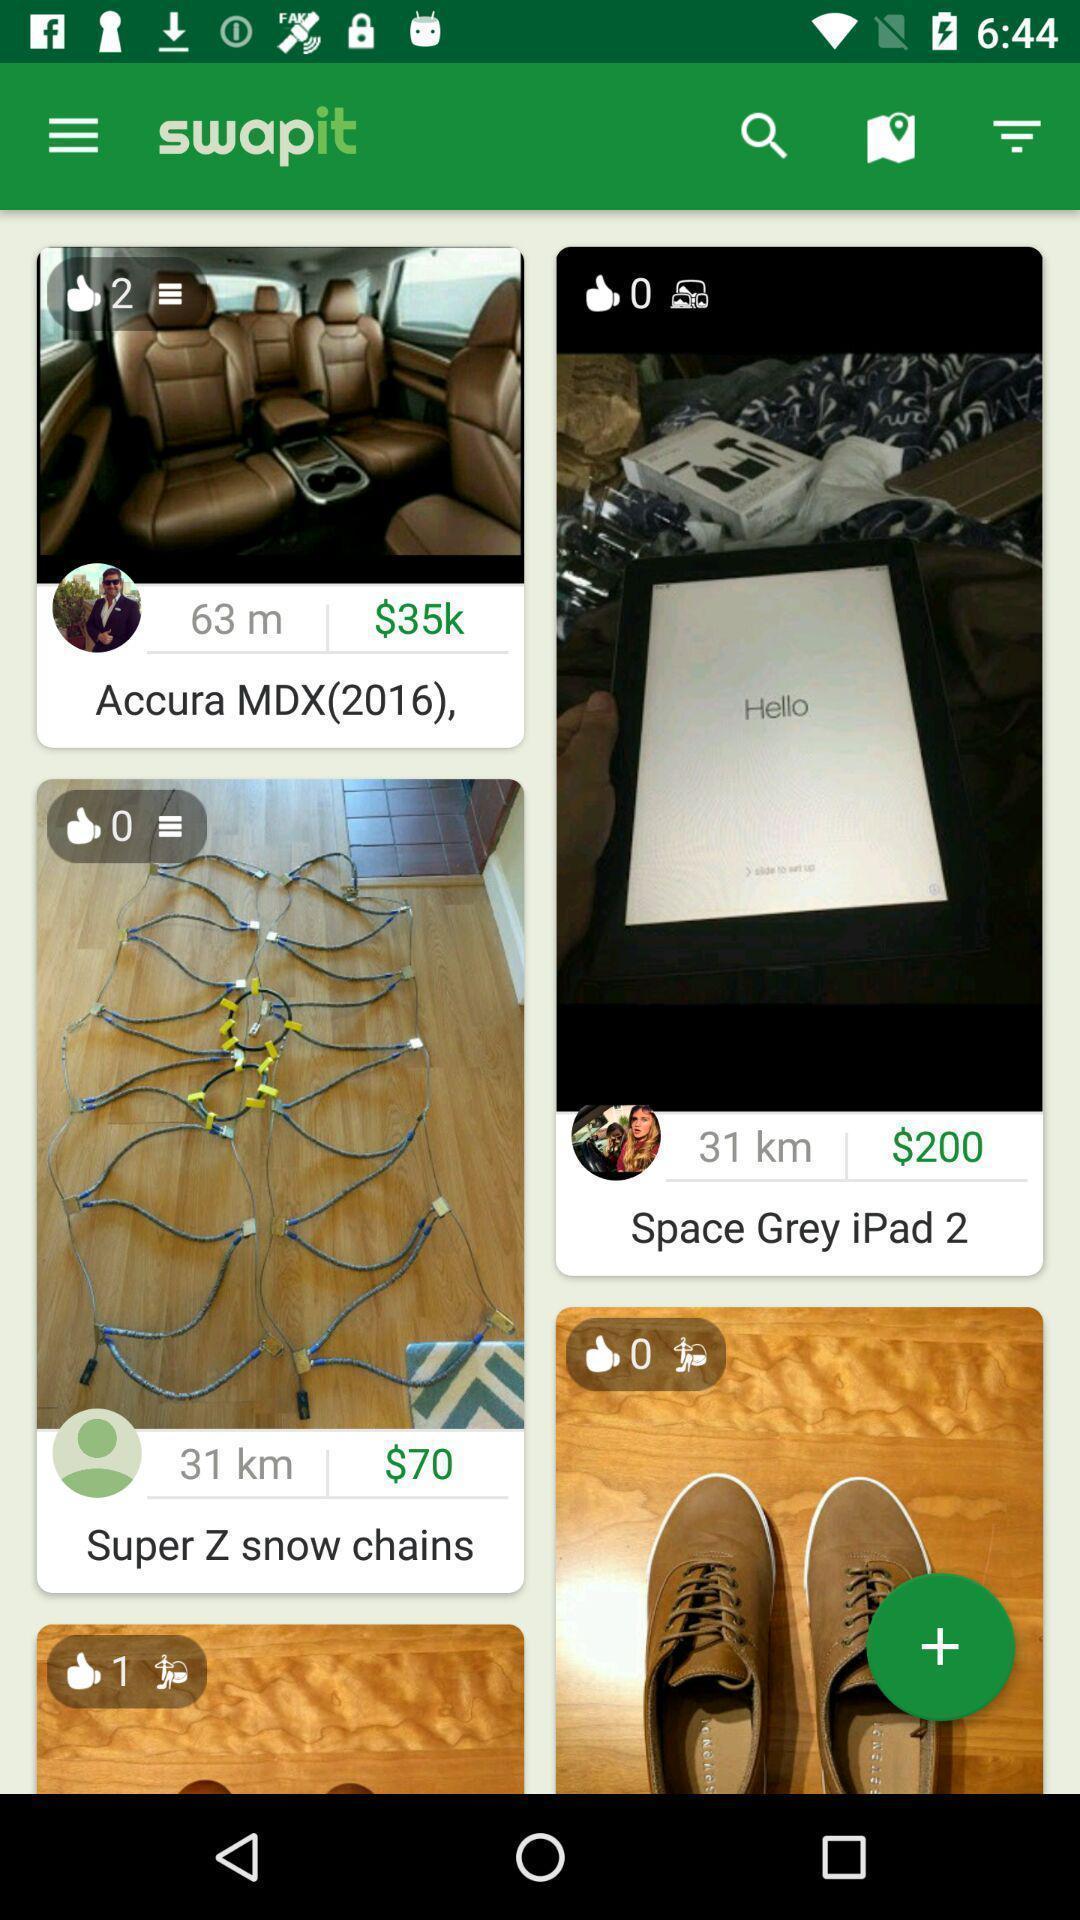Give me a narrative description of this picture. Screen shows about buyers and sellers to trade. 